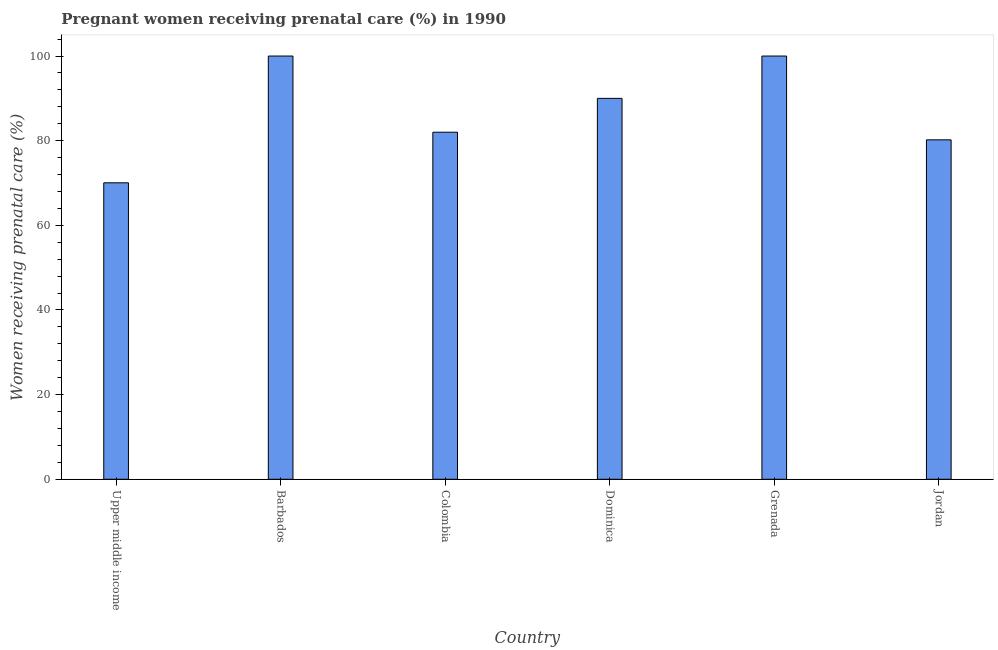Does the graph contain any zero values?
Your answer should be very brief. No. What is the title of the graph?
Your answer should be very brief. Pregnant women receiving prenatal care (%) in 1990. What is the label or title of the X-axis?
Your answer should be compact. Country. What is the label or title of the Y-axis?
Offer a terse response. Women receiving prenatal care (%). Across all countries, what is the minimum percentage of pregnant women receiving prenatal care?
Your answer should be very brief. 70.05. In which country was the percentage of pregnant women receiving prenatal care maximum?
Give a very brief answer. Barbados. In which country was the percentage of pregnant women receiving prenatal care minimum?
Your response must be concise. Upper middle income. What is the sum of the percentage of pregnant women receiving prenatal care?
Your answer should be compact. 522.25. What is the difference between the percentage of pregnant women receiving prenatal care in Colombia and Dominica?
Provide a succinct answer. -8. What is the average percentage of pregnant women receiving prenatal care per country?
Ensure brevity in your answer.  87.04. What is the ratio of the percentage of pregnant women receiving prenatal care in Grenada to that in Upper middle income?
Ensure brevity in your answer.  1.43. Is the sum of the percentage of pregnant women receiving prenatal care in Barbados and Jordan greater than the maximum percentage of pregnant women receiving prenatal care across all countries?
Keep it short and to the point. Yes. What is the difference between the highest and the lowest percentage of pregnant women receiving prenatal care?
Ensure brevity in your answer.  29.95. In how many countries, is the percentage of pregnant women receiving prenatal care greater than the average percentage of pregnant women receiving prenatal care taken over all countries?
Your response must be concise. 3. Are all the bars in the graph horizontal?
Make the answer very short. No. What is the difference between two consecutive major ticks on the Y-axis?
Your answer should be compact. 20. What is the Women receiving prenatal care (%) of Upper middle income?
Provide a succinct answer. 70.05. What is the Women receiving prenatal care (%) in Colombia?
Offer a very short reply. 82. What is the Women receiving prenatal care (%) in Grenada?
Provide a succinct answer. 100. What is the Women receiving prenatal care (%) of Jordan?
Your answer should be very brief. 80.2. What is the difference between the Women receiving prenatal care (%) in Upper middle income and Barbados?
Offer a terse response. -29.95. What is the difference between the Women receiving prenatal care (%) in Upper middle income and Colombia?
Offer a terse response. -11.95. What is the difference between the Women receiving prenatal care (%) in Upper middle income and Dominica?
Provide a short and direct response. -19.95. What is the difference between the Women receiving prenatal care (%) in Upper middle income and Grenada?
Your answer should be compact. -29.95. What is the difference between the Women receiving prenatal care (%) in Upper middle income and Jordan?
Provide a succinct answer. -10.15. What is the difference between the Women receiving prenatal care (%) in Barbados and Colombia?
Offer a very short reply. 18. What is the difference between the Women receiving prenatal care (%) in Barbados and Dominica?
Ensure brevity in your answer.  10. What is the difference between the Women receiving prenatal care (%) in Barbados and Grenada?
Your answer should be compact. 0. What is the difference between the Women receiving prenatal care (%) in Barbados and Jordan?
Provide a short and direct response. 19.8. What is the difference between the Women receiving prenatal care (%) in Dominica and Jordan?
Your response must be concise. 9.8. What is the difference between the Women receiving prenatal care (%) in Grenada and Jordan?
Provide a succinct answer. 19.8. What is the ratio of the Women receiving prenatal care (%) in Upper middle income to that in Colombia?
Make the answer very short. 0.85. What is the ratio of the Women receiving prenatal care (%) in Upper middle income to that in Dominica?
Give a very brief answer. 0.78. What is the ratio of the Women receiving prenatal care (%) in Upper middle income to that in Grenada?
Your answer should be compact. 0.7. What is the ratio of the Women receiving prenatal care (%) in Upper middle income to that in Jordan?
Provide a short and direct response. 0.87. What is the ratio of the Women receiving prenatal care (%) in Barbados to that in Colombia?
Your answer should be very brief. 1.22. What is the ratio of the Women receiving prenatal care (%) in Barbados to that in Dominica?
Your answer should be very brief. 1.11. What is the ratio of the Women receiving prenatal care (%) in Barbados to that in Jordan?
Offer a terse response. 1.25. What is the ratio of the Women receiving prenatal care (%) in Colombia to that in Dominica?
Give a very brief answer. 0.91. What is the ratio of the Women receiving prenatal care (%) in Colombia to that in Grenada?
Your response must be concise. 0.82. What is the ratio of the Women receiving prenatal care (%) in Colombia to that in Jordan?
Your answer should be compact. 1.02. What is the ratio of the Women receiving prenatal care (%) in Dominica to that in Jordan?
Give a very brief answer. 1.12. What is the ratio of the Women receiving prenatal care (%) in Grenada to that in Jordan?
Make the answer very short. 1.25. 